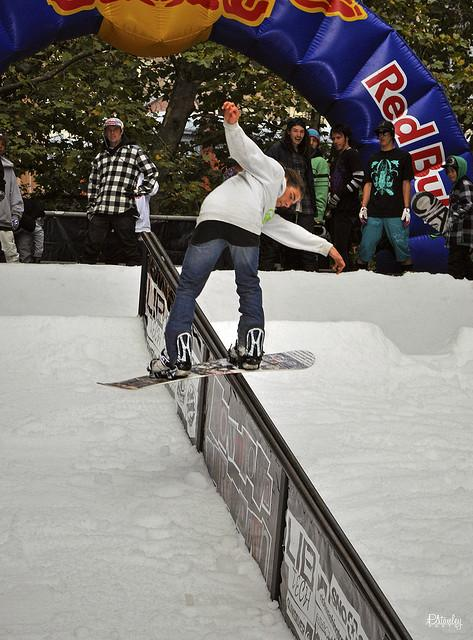What position does this player have the snowboards center point on the rail? perpendicular 